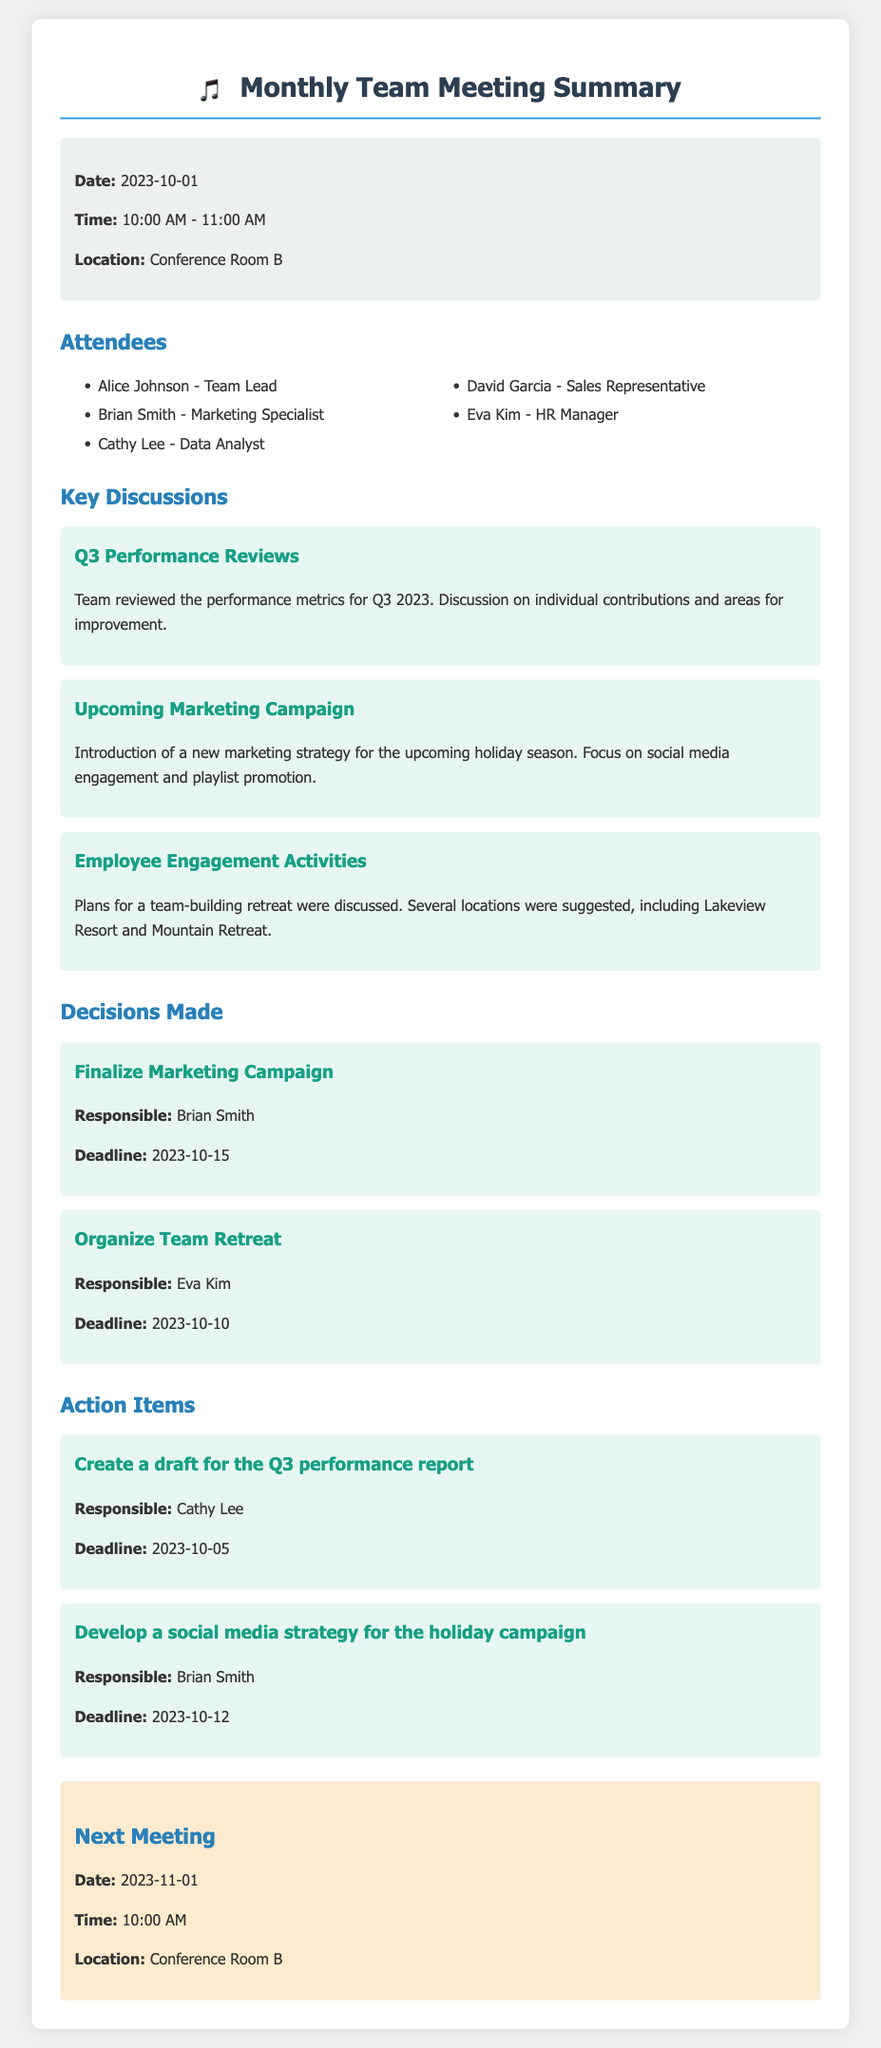What is the date of the meeting? The meeting was held on October 1, 2023.
Answer: October 1, 2023 Who is responsible for finalizing the marketing campaign? The individual responsible for finalizing the marketing campaign is mentioned in the decisions section.
Answer: Brian Smith What is the deadline for the action item to create a draft for the Q3 performance report? The deadline for this action item is provided in the action items section.
Answer: October 5, 2023 What was one of the key discussions during the meeting? The key discussions cover various topics, including performance reviews and employee engagement.
Answer: Q3 Performance Reviews When is the next meeting scheduled? The date for the next meeting is provided at the end of the document.
Answer: November 1, 2023 How many attendees were present at the meeting? The document lists the attendees in an unordered list.
Answer: Five What was discussed regarding the upcoming marketing campaign? The discussion included strategies for the holiday season and a focus area.
Answer: Social media engagement Who is organizing the team retreat? The responsible person for organizing the team retreat is stated in the decisions section.
Answer: Eva Kim 